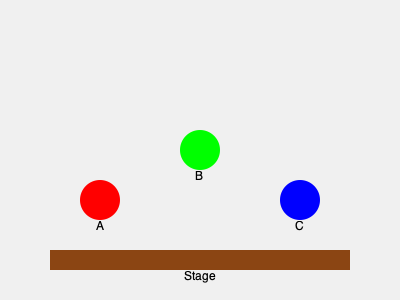Given the stage arrangement shown, where three musicians (A, B, and C) are positioned at different heights and distances from the front of the stage, which musician should be moved to create an equilateral triangle formation for optimal acoustic balance? Assume the stage depth is 10 meters and the width is 15 meters. To determine which musician should be moved to create an equilateral triangle formation, we need to follow these steps:

1. Analyze the current positions:
   - Musician A: front left
   - Musician B: center, raised
   - Musician C: front right

2. Calculate the distances between musicians:
   - Distance AB ≈ $\sqrt{5^2 + 5^2} = 5\sqrt{2} \approx 7.07$ meters
   - Distance BC ≈ $\sqrt{5^2 + 5^2} = 5\sqrt{2} \approx 7.07$ meters
   - Distance AC = 10 meters (width of the stage)

3. For an equilateral triangle, all sides should be equal. The longest current side is AC at 10 meters.

4. To create an equilateral triangle with 10-meter sides:
   - Keep A and C in their current positions
   - Move B to form the apex of the equilateral triangle

5. Calculate the new position for B:
   - Height of the equilateral triangle: $h = \sqrt{10^2 - 5^2} = 5\sqrt{3} \approx 8.66$ meters
   - B should be moved back $8.66$ meters from the line connecting A and C

6. The new position for B would be:
   - 7.5 meters from the left edge of the stage (midpoint between A and C)
   - 8.66 meters from the front of the stage

Therefore, musician B needs to be moved to create the equilateral triangle formation for optimal acoustic balance.
Answer: Musician B 